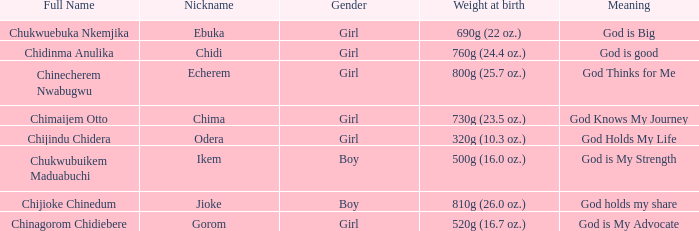What nickname has the meaning of God knows my journey? Chima. 